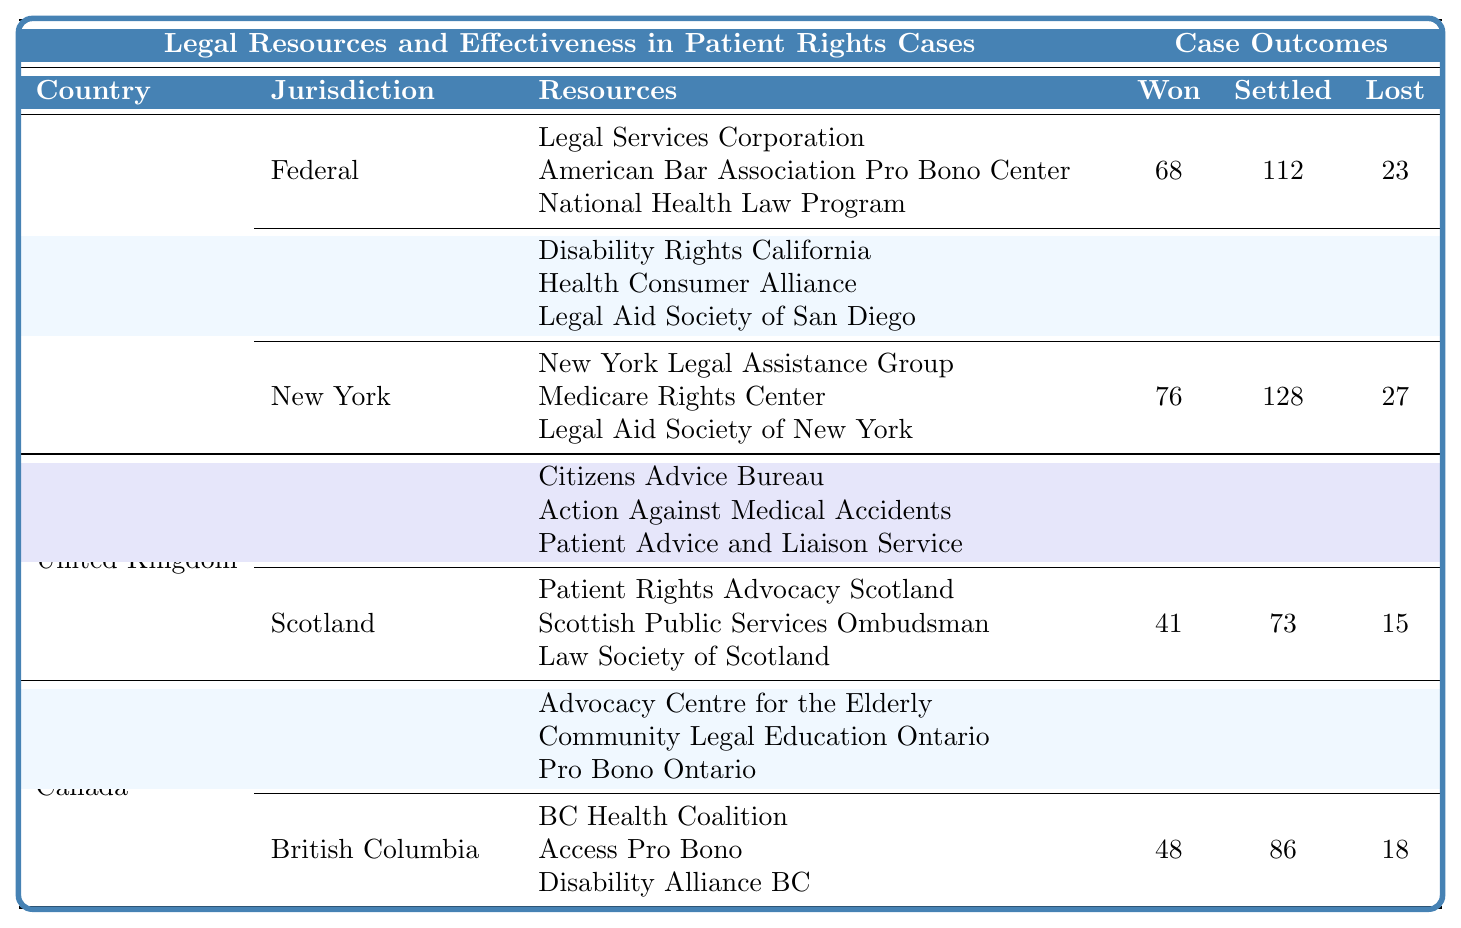What jurisdiction has the highest number of cases won? By examining the "Cases Won" column for each jurisdiction, California has 89 cases won, which is higher than the other jurisdictions listed (United States Federal: 68, New York: 76, England and Wales: 54, Scotland: 41, Ontario: 62, British Columbia: 48).
Answer: California Which resource had the least amount of cases settled in the United Kingdom? By looking at the "Settled" column, Scotland has the least cases settled with 73, compared to England and Wales with 97.
Answer: Scotland What is the total number of cases lost in the United States? To find the total cases lost in the United States, we add the lost cases from each jurisdiction: 23 (Federal) + 31 (California) + 27 (New York) = 81.
Answer: 81 True or False: The effectiveness of the resources in Ontario had more cases won than those in British Columbia. The number of cases won in Ontario is 62, while in British Columbia, it is 48. Therefore, the statement is true.
Answer: True What is the average number of cases settled across all jurisdictions listed? We sum the cases settled: 112 (Federal) + 143 (California) + 128 (New York) + 97 (England and Wales) + 73 (Scotland) + 104 (Ontario) + 86 (British Columbia) = 843. There are 7 jurisdictions, so the average is 843/7 = 120.43.
Answer: 120.43 Which country has the lowest total effectiveness based on cases lost? In comparing the total cases lost: United States has 81, United Kingdom has 34 (54 in England and Wales and 41 in Scotland), and Canada has 40 (22 in Ontario and 18 in British Columbia). The United Kingdom has the lowest total cases lost.
Answer: United Kingdom In which jurisdiction is the effectiveness of legal resources the highest based on the ratio of cases won to cases lost? The ratio of cases won to lost in California (89/31 = 2.87) is higher than in any other jurisdiction. The next highest is New York (76/27 = 2.81) and the Federal (68/23 = 2.96). Thus, California has the highest ratio.
Answer: California What jurisdiction had the greatest disparity between cases won and lost? The disparity for each jurisdiction is calculated as the difference between cases won and lost: Federal (68 - 23 = 45), California (89 - 31 = 58), New York (76 - 27 = 49), England and Wales (54 - 19 = 35), Scotland (41 - 15 = 26), Ontario (62 - 22 = 40), British Columbia (48 - 18 = 30). California has the greatest disparity of 58.
Answer: California 